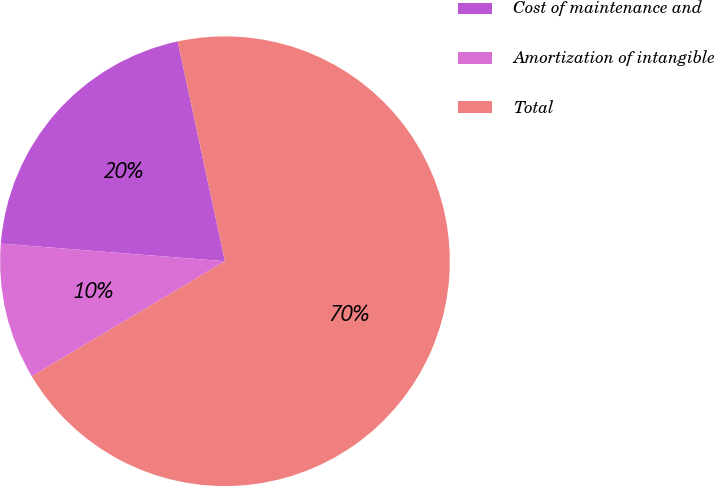<chart> <loc_0><loc_0><loc_500><loc_500><pie_chart><fcel>Cost of maintenance and<fcel>Amortization of intangible<fcel>Total<nl><fcel>20.38%<fcel>9.8%<fcel>69.82%<nl></chart> 